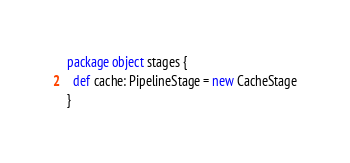Convert code to text. <code><loc_0><loc_0><loc_500><loc_500><_Scala_>package object stages {
  def cache: PipelineStage = new CacheStage
}
</code> 